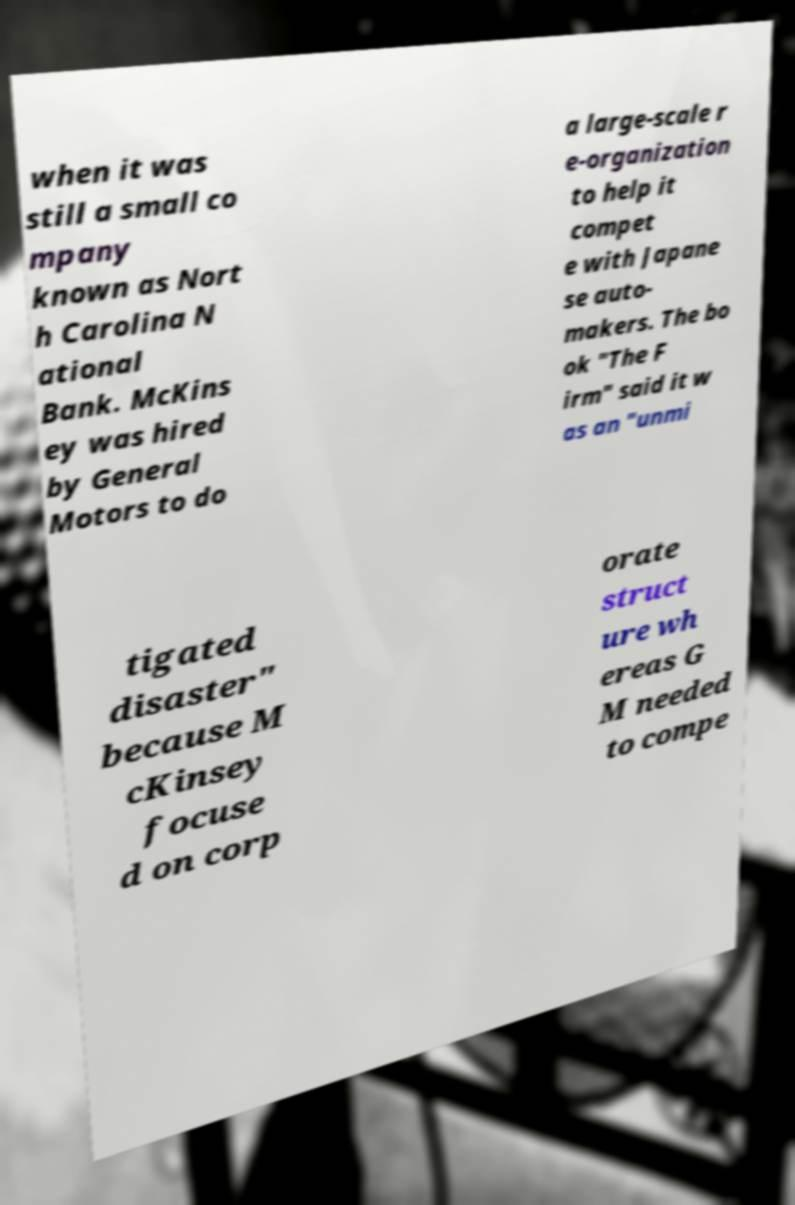Could you assist in decoding the text presented in this image and type it out clearly? when it was still a small co mpany known as Nort h Carolina N ational Bank. McKins ey was hired by General Motors to do a large-scale r e-organization to help it compet e with Japane se auto- makers. The bo ok "The F irm" said it w as an "unmi tigated disaster" because M cKinsey focuse d on corp orate struct ure wh ereas G M needed to compe 